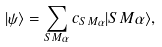<formula> <loc_0><loc_0><loc_500><loc_500>| \psi \rangle = \sum _ { S M \alpha } c _ { S M \alpha } { | { S M \alpha } \rangle } ,</formula> 